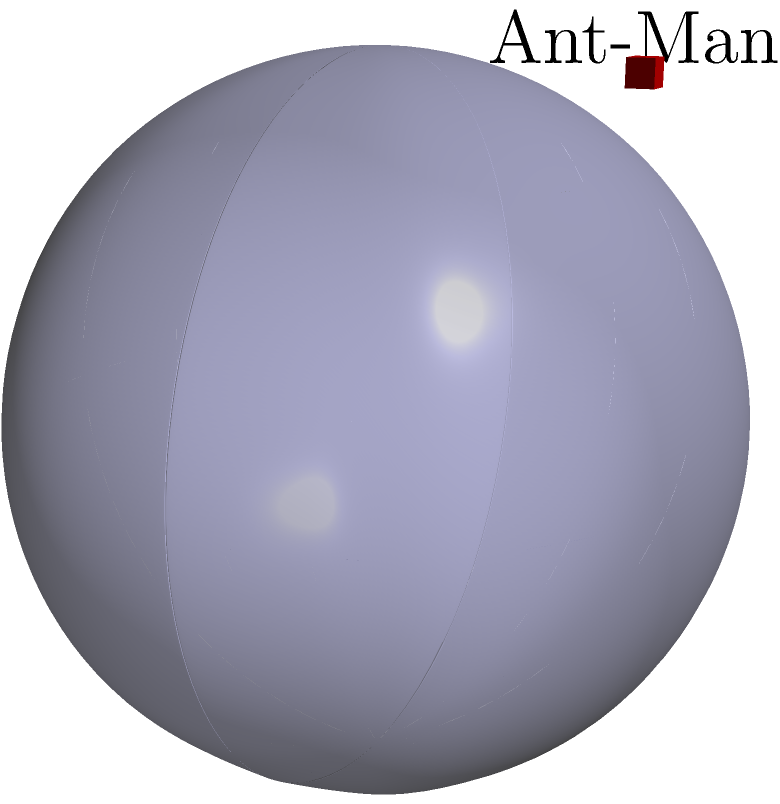In the Quantum Realm, Ant-Man encounters a spherical region with radius 2 units. Calculate the volume of this quantum sphere using triple integrals in spherical coordinates. Assume the sphere is centered at the origin and Ant-Man is located at the point (2,2,2). To calculate the volume of the sphere using triple integrals in spherical coordinates, we'll follow these steps:

1) The general formula for volume using triple integrals in spherical coordinates is:

   $$V = \int_0^{2\pi} \int_0^{\pi} \int_0^R r^2 \sin(\phi) \, dr \, d\phi \, d\theta$$

   Where $R$ is the radius of the sphere, $\theta$ is the azimuthal angle in the x-y plane from the x-axis (0 to 2π), and $\phi$ is the polar angle from the z-axis (0 to π).

2) In this case, $R = 2$. Let's substitute this into our integral:

   $$V = \int_0^{2\pi} \int_0^{\pi} \int_0^2 r^2 \sin(\phi) \, dr \, d\phi \, d\theta$$

3) Let's solve the innermost integral first:

   $$\int_0^2 r^2 \, dr = \left[\frac{1}{3}r^3\right]_0^2 = \frac{8}{3}$$

4) Our integral now looks like this:

   $$V = \int_0^{2\pi} \int_0^{\pi} \frac{8}{3} \sin(\phi) \, d\phi \, d\theta$$

5) Now, let's solve the $\phi$ integral:

   $$\int_0^{\pi} \sin(\phi) \, d\phi = [-\cos(\phi)]_0^{\pi} = 2$$

6) Our integral is now:

   $$V = \int_0^{2\pi} \frac{16}{3} \, d\theta$$

7) Finally, we can solve this:

   $$V = \left[\frac{16}{3}\theta\right]_0^{2\pi} = \frac{32\pi}{3}$$

Thus, the volume of the quantum sphere is $\frac{32\pi}{3}$ cubic units.
Answer: $\frac{32\pi}{3}$ cubic units 